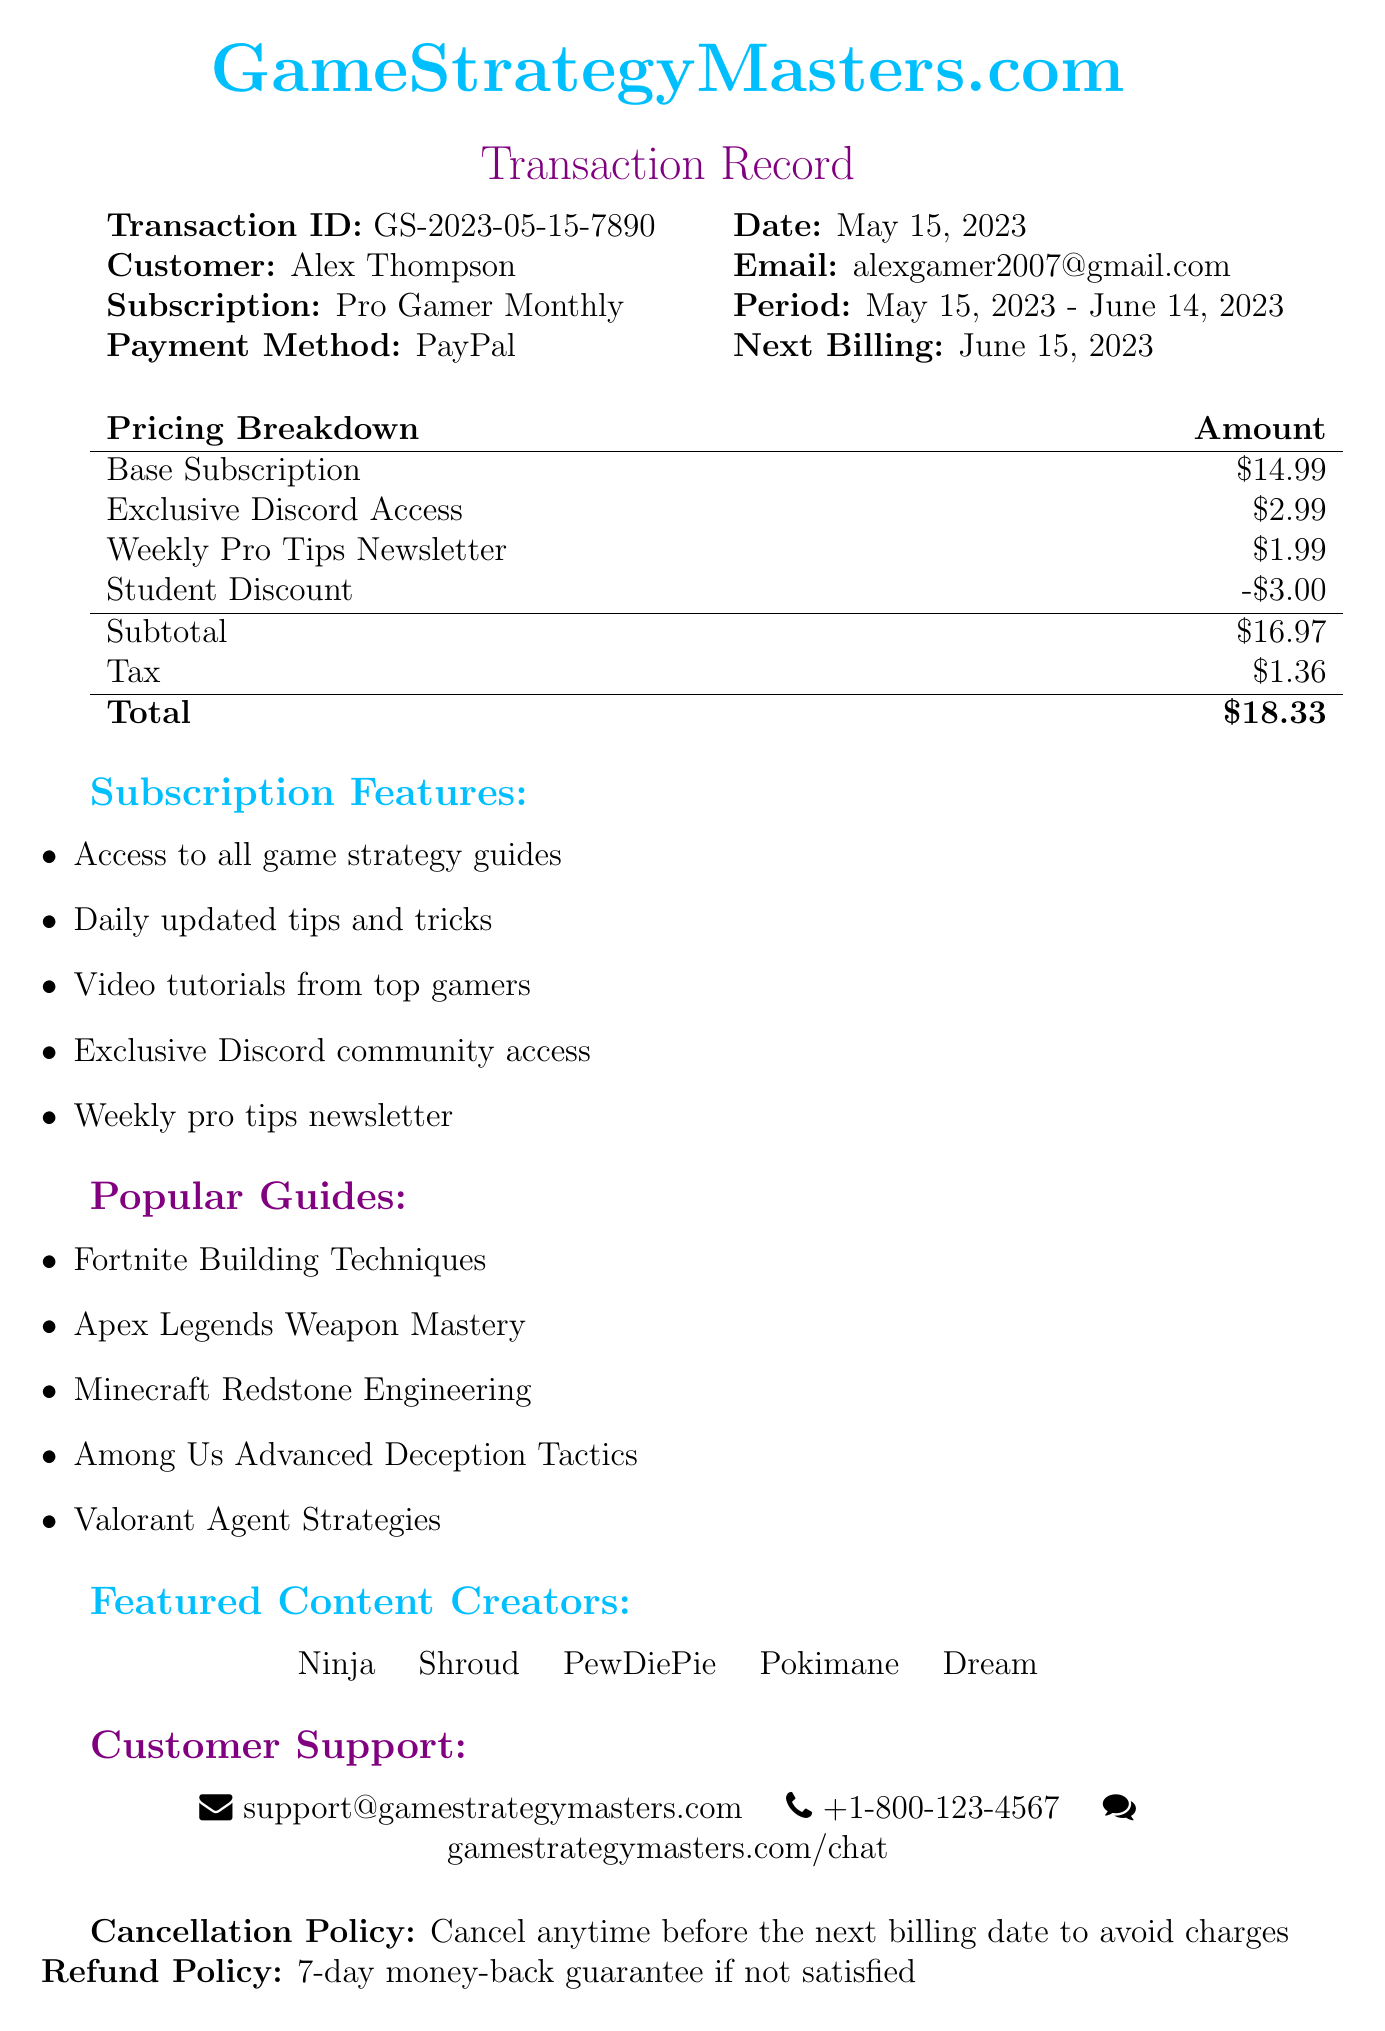What is the transaction ID? The transaction ID is specifically mentioned in the document as GS-2023-05-15-7890.
Answer: GS-2023-05-15-7890 Who is the customer? The document lists the customer's name as Alex Thompson.
Answer: Alex Thompson What is the total amount charged? The total amount charged is presented clearly as $18.33 in the pricing breakdown section.
Answer: $18.33 What discount was applied? The document indicates a student discount of $3.00.
Answer: $3.00 What payment method was used? The payment method used for the transaction is specified as PayPal.
Answer: PayPal What is the cancellation policy? The cancellation policy is summarized as “Cancel anytime before the next billing date to avoid charges.”
Answer: Cancel anytime before the next billing date to avoid charges What features are included in the subscription? The features included in the subscription can be found in a list and include items like access to all game strategy guides.
Answer: Access to all game strategy guides When is the next billing date? The next billing date is mentioned as June 15, 2023.
Answer: June 15, 2023 Which popular guide is mentioned? The document includes a list of popular guides such as “Fortnite Building Techniques.”
Answer: Fortnite Building Techniques 